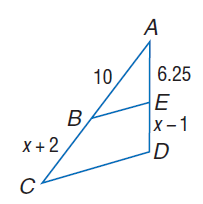Answer the mathemtical geometry problem and directly provide the correct option letter.
Question: Each pair of polygons is similar. Find E D.
Choices: A: 5 B: 6.25 C: 10 D: 95 A 